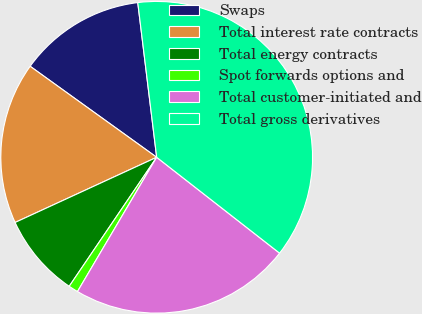Convert chart to OTSL. <chart><loc_0><loc_0><loc_500><loc_500><pie_chart><fcel>Swaps<fcel>Total interest rate contracts<fcel>Total energy contracts<fcel>Spot forwards options and<fcel>Total customer-initiated and<fcel>Total gross derivatives<nl><fcel>13.14%<fcel>16.79%<fcel>8.65%<fcel>1.0%<fcel>22.94%<fcel>37.48%<nl></chart> 